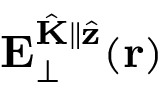<formula> <loc_0><loc_0><loc_500><loc_500>E _ { \perp } ^ { \hat { K } \| \hat { z } } ( r )</formula> 